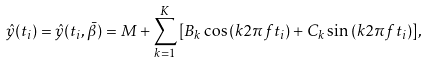<formula> <loc_0><loc_0><loc_500><loc_500>\hat { y } ( t _ { i } ) = \hat { y } ( t _ { i } , \bar { \beta } ) = M + \sum _ { k = 1 } ^ { K } { [ B _ { k } \cos { ( k 2 \pi f t _ { i } ) } + C _ { k } \sin { ( k 2 \pi f t _ { i } ) } ] } ,</formula> 